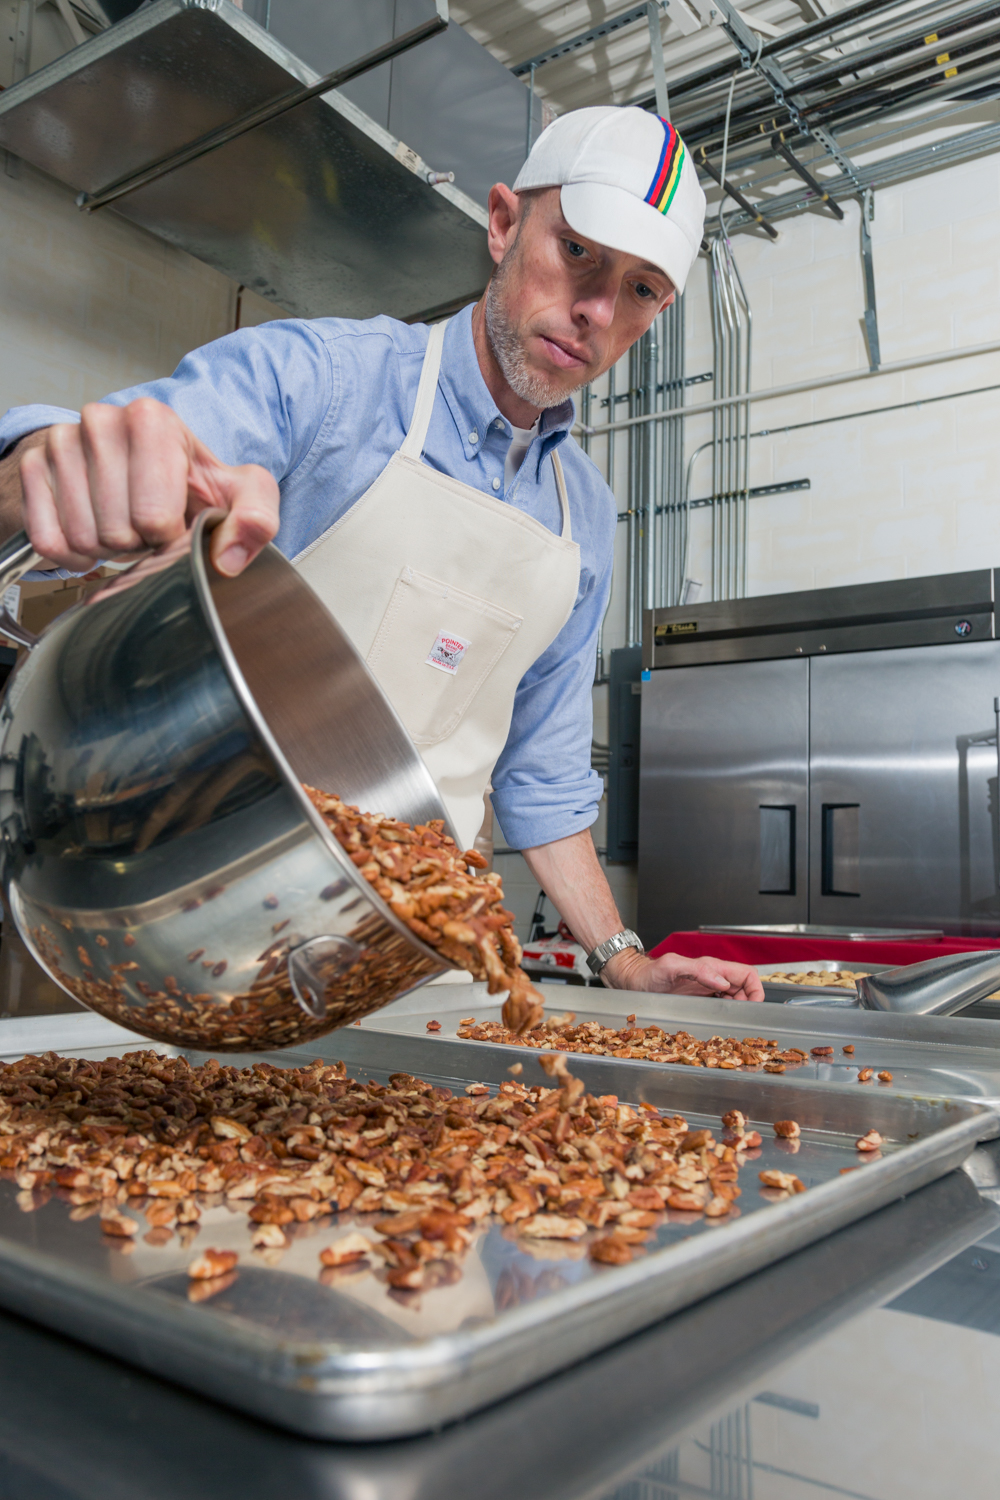Considering the man's attire and the equipment present in the kitchen, what might be the scale of production this kitchen is designed for, and what kind of establishment could this kitchen be a part of? Looking at the man's attire, with his clean apron and cap, along with the commercial-grade kitchen equipment like the large oven, refrigerator, and the substantial stainless steel pot he’s using to roast nuts, it’s clear that this kitchen is designed for a reasonably large-scale production. The presence of specific tools for handling large quantities of nuts indicates that this could be a professional establishment such as a bakery, confectionery facility, or a catering business. The man appears to be a professional, adhering to stringent food safety and hygiene standards, as suggested by his use of a cap and apron. Such kitchens are often found in businesses that require the preparation of food in substantial batches to meet client demand. 